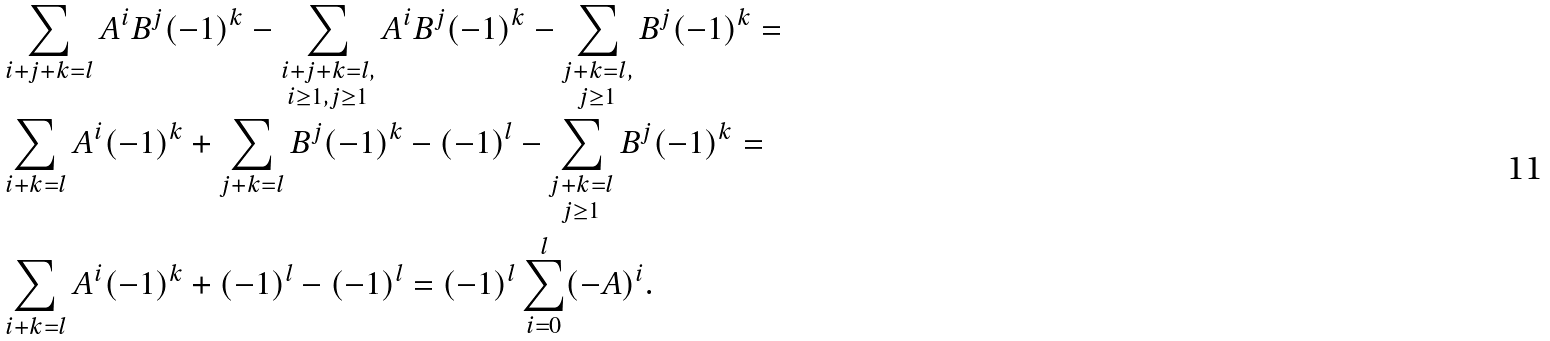<formula> <loc_0><loc_0><loc_500><loc_500>& \sum _ { i + j + k = l } A ^ { i } B ^ { j } ( - 1 ) ^ { k } - \sum _ { \substack { i + j + k = l , \\ i \geq 1 , j \geq 1 } } A ^ { i } B ^ { j } ( - 1 ) ^ { k } - \sum _ { \substack { j + k = l , \\ j \geq 1 } } B ^ { j } ( - 1 ) ^ { k } = \\ & \sum _ { i + k = l } A ^ { i } ( - 1 ) ^ { k } + \sum _ { j + k = l } B ^ { j } ( - 1 ) ^ { k } - ( - 1 ) ^ { l } - \sum _ { \substack { j + k = l \\ j \geq 1 } } B ^ { j } ( - 1 ) ^ { k } = \\ & \sum _ { i + k = l } A ^ { i } ( - 1 ) ^ { k } + ( - 1 ) ^ { l } - ( - 1 ) ^ { l } = ( - 1 ) ^ { l } \sum _ { i = 0 } ^ { l } ( - A ) ^ { i } .</formula> 